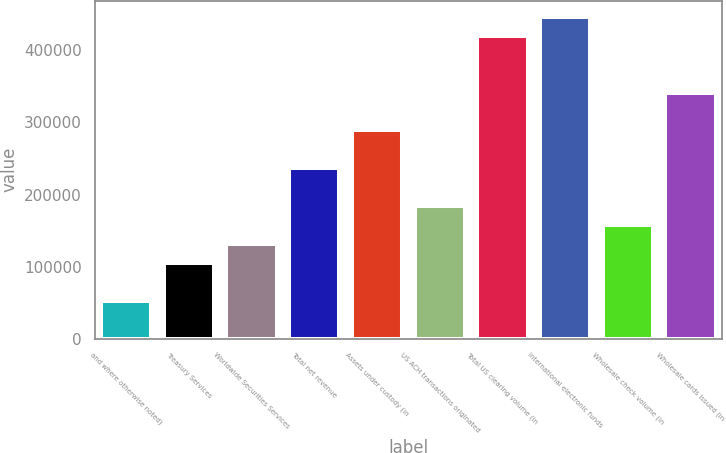Convert chart. <chart><loc_0><loc_0><loc_500><loc_500><bar_chart><fcel>and where otherwise noted)<fcel>Treasury Services<fcel>Worldwide Securities Services<fcel>Total net revenue<fcel>Assets under custody (in<fcel>US ACH transactions originated<fcel>Total US clearing volume (in<fcel>International electronic funds<fcel>Wholesale check volume (in<fcel>Wholesale cards issued (in<nl><fcel>52580.4<fcel>105105<fcel>131367<fcel>236416<fcel>288940<fcel>183891<fcel>420251<fcel>446513<fcel>157629<fcel>341465<nl></chart> 